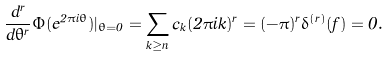Convert formula to latex. <formula><loc_0><loc_0><loc_500><loc_500>\frac { d ^ { r } } { d \theta ^ { r } } \Phi ( e ^ { 2 \pi i \theta } ) | _ { \theta = 0 } = \sum _ { k \geq n } c _ { k } ( 2 \pi i k ) ^ { r } = ( - \pi ) ^ { r } \delta ^ { ( r ) } ( f ) = 0 .</formula> 